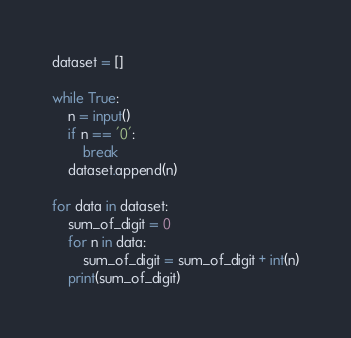<code> <loc_0><loc_0><loc_500><loc_500><_Python_>dataset = []

while True:
    n = input()
    if n == '0':
        break
    dataset.append(n)

for data in dataset:
    sum_of_digit = 0
    for n in data:
        sum_of_digit = sum_of_digit + int(n)
    print(sum_of_digit)
</code> 